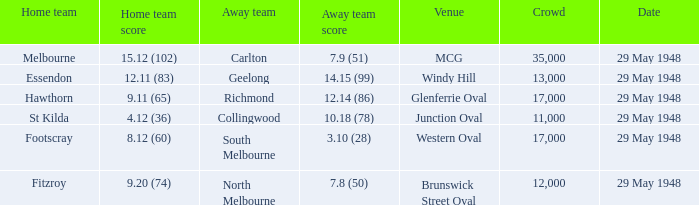During melbourne's home game, who was the away team? Carlton. 